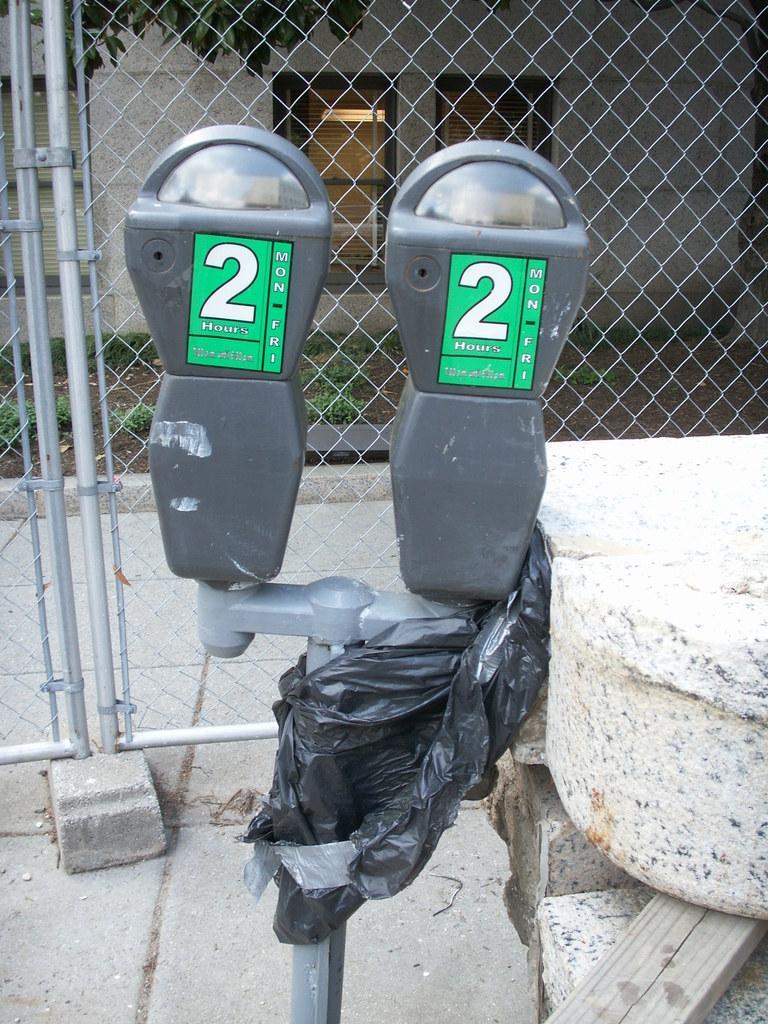Describe this image in one or two sentences. In the center of the image we can see parking meters. On the right there are rocks. In the background we can see a mesh, tree and a building. 